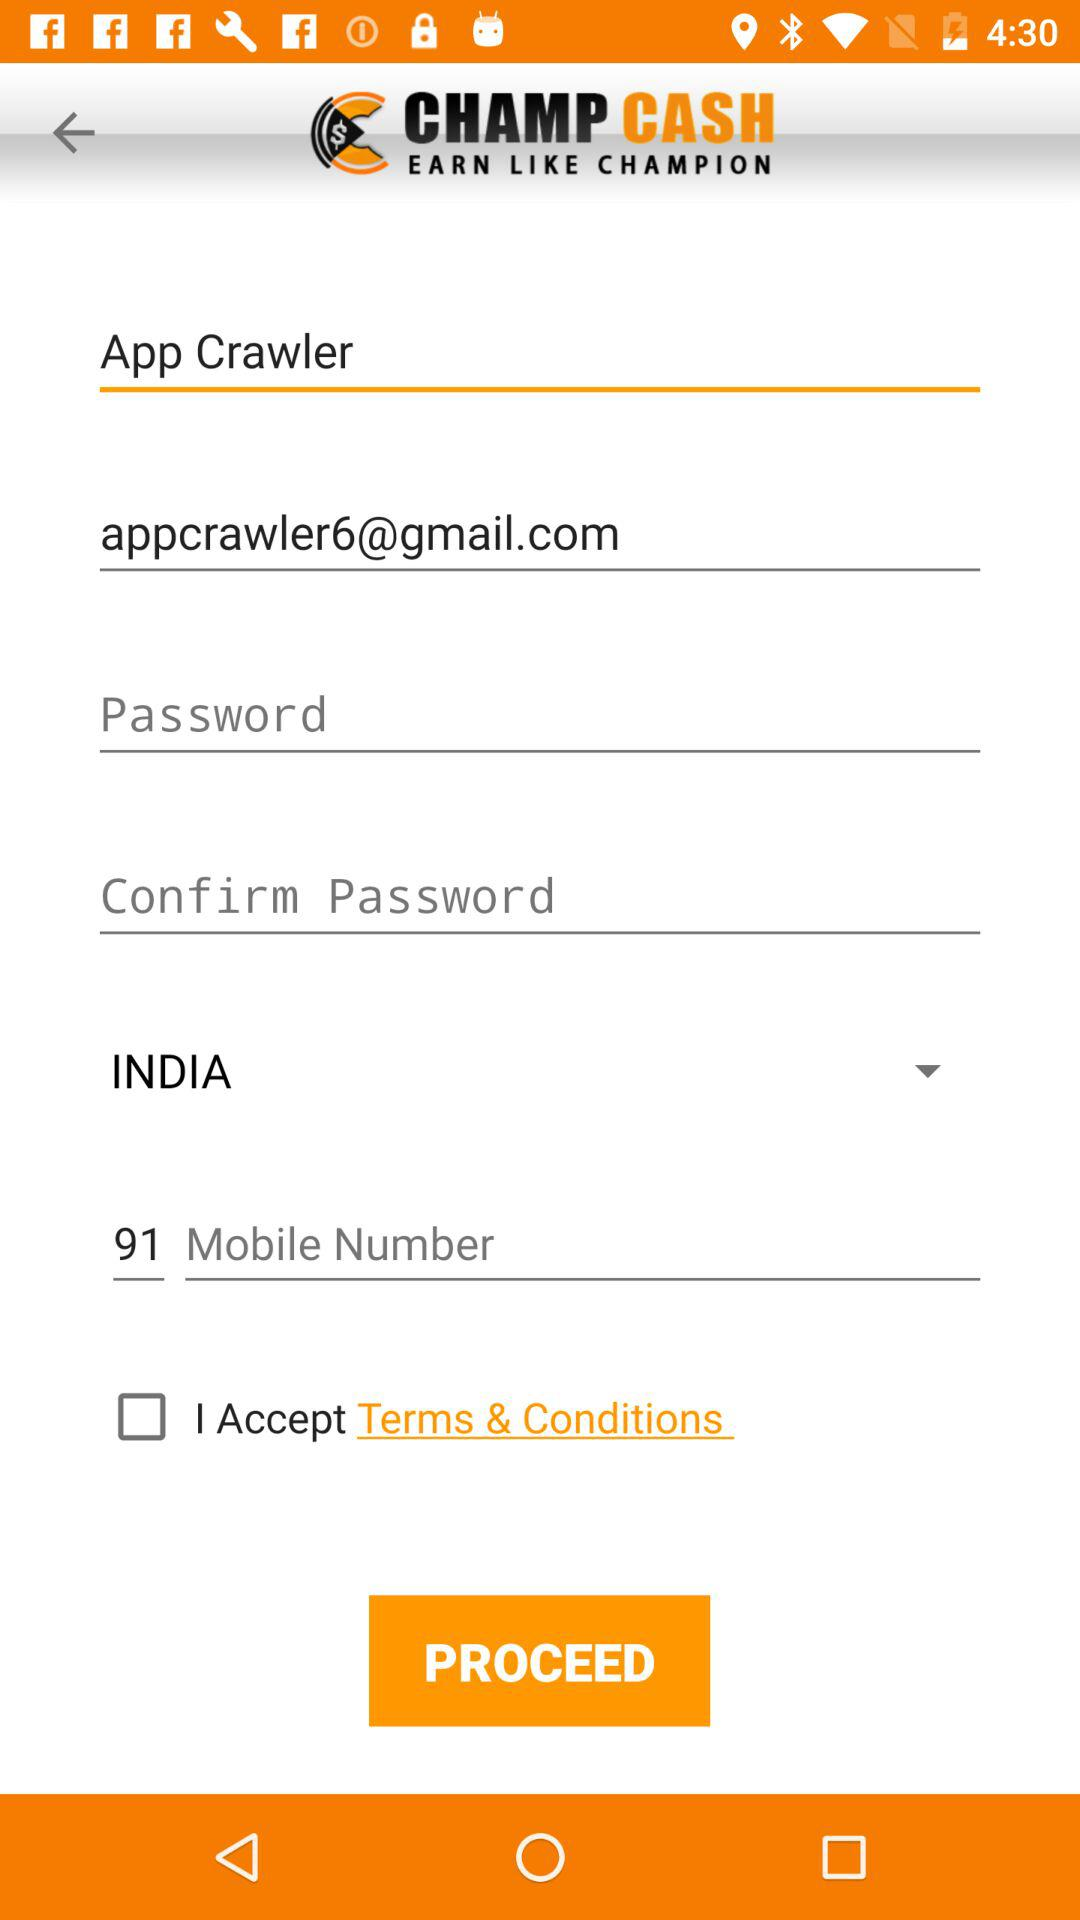What is the code of the country? The code of the country is 91. 